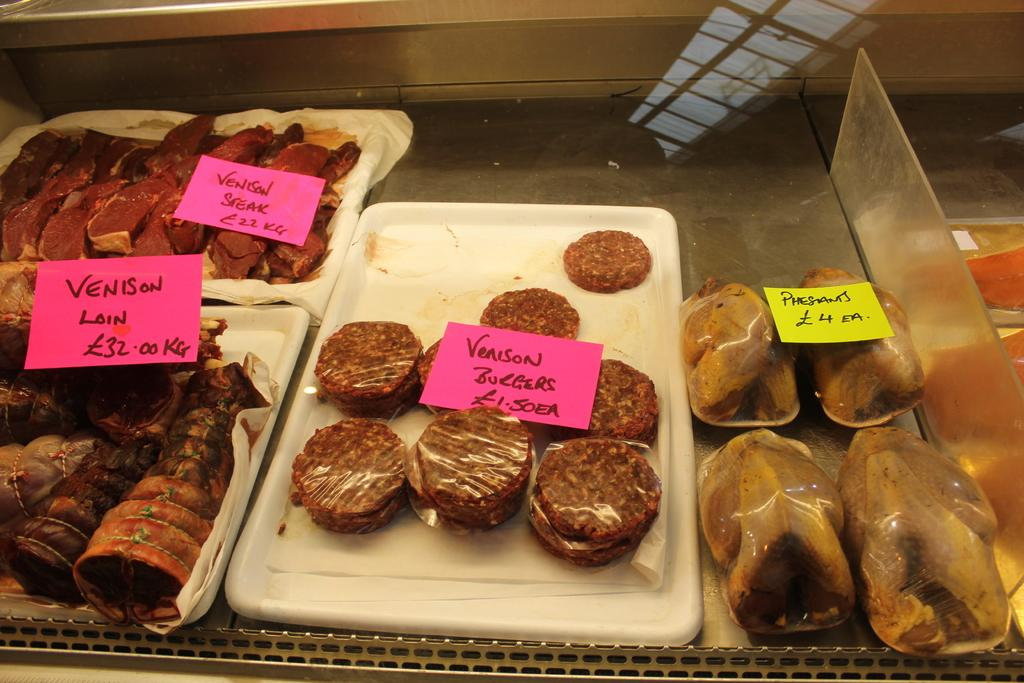What is located in the foreground of the image? There are food items in a tray in the foreground of the image. What type of surface is the food placed on? The food items are on a steel surface. How can the food items be identified in the image? There are price tags and names associated with the food items. What can be seen on the right side of the image? There is a glass on the right side of the image. What type of creature is playing a horn in the image? There is no creature playing a horn in the image; it only features food items in a tray, a steel surface, price tags, names, and a glass. 